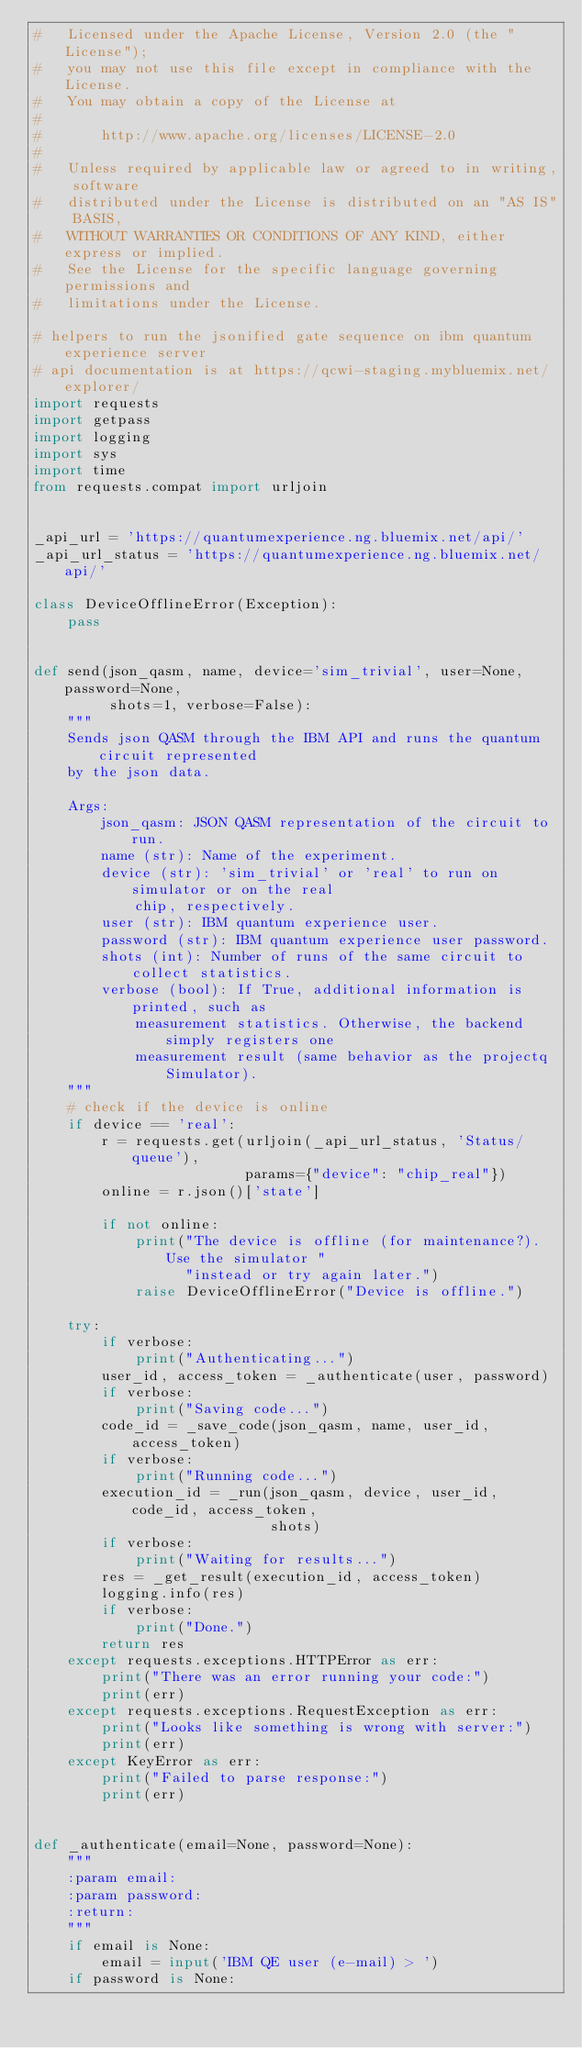Convert code to text. <code><loc_0><loc_0><loc_500><loc_500><_Python_>#   Licensed under the Apache License, Version 2.0 (the "License");
#   you may not use this file except in compliance with the License.
#   You may obtain a copy of the License at
#
#       http://www.apache.org/licenses/LICENSE-2.0
#
#   Unless required by applicable law or agreed to in writing, software
#   distributed under the License is distributed on an "AS IS" BASIS,
#   WITHOUT WARRANTIES OR CONDITIONS OF ANY KIND, either express or implied.
#   See the License for the specific language governing permissions and
#   limitations under the License.

# helpers to run the jsonified gate sequence on ibm quantum experience server
# api documentation is at https://qcwi-staging.mybluemix.net/explorer/
import requests
import getpass
import logging
import sys
import time
from requests.compat import urljoin


_api_url = 'https://quantumexperience.ng.bluemix.net/api/'
_api_url_status = 'https://quantumexperience.ng.bluemix.net/api/'

class DeviceOfflineError(Exception):
	pass


def send(json_qasm, name, device='sim_trivial', user=None, password=None,
         shots=1, verbose=False):
	"""
	Sends json QASM through the IBM API and runs the quantum circuit represented
	by the json data.
	
	Args:
		json_qasm: JSON QASM representation of the circuit to run.
		name (str): Name of the experiment.
		device (str): 'sim_trivial' or 'real' to run on simulator or on the real
			chip, respectively.
		user (str): IBM quantum experience user.
		password (str): IBM quantum experience user password.
		shots (int): Number of runs of the same circuit to collect statistics.
		verbose (bool): If True, additional information is printed, such as
			measurement statistics. Otherwise, the backend simply registers one
			measurement result (same behavior as the projectq Simulator).
	"""
	# check if the device is online
	if device == 'real':
		r = requests.get(urljoin(_api_url_status, 'Status/queue'),
		                 params={"device": "chip_real"})
		online = r.json()['state']
		
		if not online:
			print("The device is offline (for maintenance?). Use the simulator "
			      "instead or try again later.")
			raise DeviceOfflineError("Device is offline.")
	
	try:
		if verbose:
			print("Authenticating...")
		user_id, access_token = _authenticate(user, password)
		if verbose:
			print("Saving code...")
		code_id = _save_code(json_qasm, name, user_id, access_token)
		if verbose:
			print("Running code...")
		execution_id = _run(json_qasm, device, user_id, code_id, access_token,
		                    shots)
		if verbose:
			print("Waiting for results...")
		res = _get_result(execution_id, access_token)
		logging.info(res)
		if verbose:
			print("Done.")
		return res
	except requests.exceptions.HTTPError as err:
		print("There was an error running your code:")
		print(err)
	except requests.exceptions.RequestException as err:
		print("Looks like something is wrong with server:")
		print(err)
	except KeyError as err:
		print("Failed to parse response:")
		print(err)


def _authenticate(email=None, password=None):
	"""
	:param email:
	:param password:
	:return:
	"""
	if email is None:
		email = input('IBM QE user (e-mail) > ')
	if password is None:</code> 